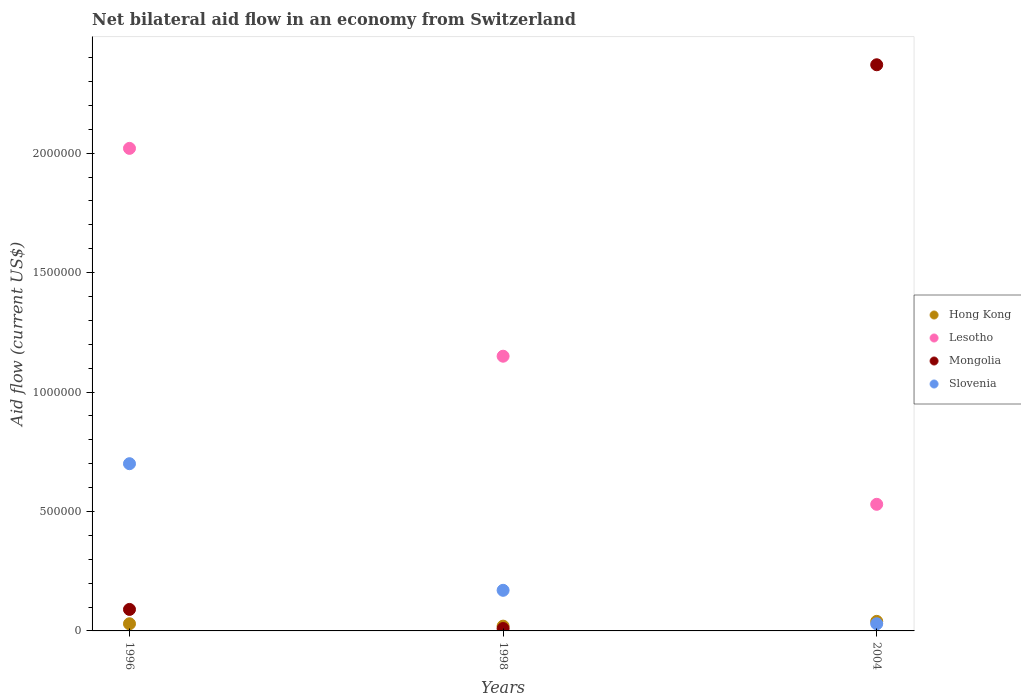Is the number of dotlines equal to the number of legend labels?
Offer a very short reply. Yes. What is the net bilateral aid flow in Slovenia in 1998?
Your answer should be compact. 1.70e+05. Across all years, what is the minimum net bilateral aid flow in Lesotho?
Your answer should be compact. 5.30e+05. In which year was the net bilateral aid flow in Slovenia maximum?
Your answer should be very brief. 1996. In which year was the net bilateral aid flow in Slovenia minimum?
Your answer should be compact. 2004. What is the total net bilateral aid flow in Lesotho in the graph?
Your answer should be compact. 3.70e+06. What is the average net bilateral aid flow in Mongolia per year?
Provide a short and direct response. 8.23e+05. Is the difference between the net bilateral aid flow in Hong Kong in 1996 and 1998 greater than the difference between the net bilateral aid flow in Mongolia in 1996 and 1998?
Your answer should be compact. No. What is the difference between the highest and the second highest net bilateral aid flow in Lesotho?
Your response must be concise. 8.70e+05. What is the difference between the highest and the lowest net bilateral aid flow in Lesotho?
Ensure brevity in your answer.  1.49e+06. In how many years, is the net bilateral aid flow in Mongolia greater than the average net bilateral aid flow in Mongolia taken over all years?
Give a very brief answer. 1. Is it the case that in every year, the sum of the net bilateral aid flow in Lesotho and net bilateral aid flow in Hong Kong  is greater than the sum of net bilateral aid flow in Mongolia and net bilateral aid flow in Slovenia?
Provide a succinct answer. Yes. What is the difference between two consecutive major ticks on the Y-axis?
Provide a succinct answer. 5.00e+05. Are the values on the major ticks of Y-axis written in scientific E-notation?
Give a very brief answer. No. Does the graph contain any zero values?
Your response must be concise. No. Where does the legend appear in the graph?
Your answer should be very brief. Center right. How many legend labels are there?
Make the answer very short. 4. How are the legend labels stacked?
Give a very brief answer. Vertical. What is the title of the graph?
Make the answer very short. Net bilateral aid flow in an economy from Switzerland. What is the label or title of the Y-axis?
Offer a very short reply. Aid flow (current US$). What is the Aid flow (current US$) of Hong Kong in 1996?
Your answer should be very brief. 3.00e+04. What is the Aid flow (current US$) in Lesotho in 1996?
Make the answer very short. 2.02e+06. What is the Aid flow (current US$) of Slovenia in 1996?
Your response must be concise. 7.00e+05. What is the Aid flow (current US$) in Hong Kong in 1998?
Provide a short and direct response. 2.00e+04. What is the Aid flow (current US$) in Lesotho in 1998?
Offer a terse response. 1.15e+06. What is the Aid flow (current US$) of Slovenia in 1998?
Your answer should be compact. 1.70e+05. What is the Aid flow (current US$) of Hong Kong in 2004?
Your answer should be very brief. 4.00e+04. What is the Aid flow (current US$) of Lesotho in 2004?
Provide a succinct answer. 5.30e+05. What is the Aid flow (current US$) in Mongolia in 2004?
Give a very brief answer. 2.37e+06. Across all years, what is the maximum Aid flow (current US$) of Lesotho?
Provide a short and direct response. 2.02e+06. Across all years, what is the maximum Aid flow (current US$) in Mongolia?
Make the answer very short. 2.37e+06. Across all years, what is the maximum Aid flow (current US$) in Slovenia?
Your response must be concise. 7.00e+05. Across all years, what is the minimum Aid flow (current US$) of Lesotho?
Offer a very short reply. 5.30e+05. Across all years, what is the minimum Aid flow (current US$) in Mongolia?
Your answer should be very brief. 10000. Across all years, what is the minimum Aid flow (current US$) in Slovenia?
Keep it short and to the point. 3.00e+04. What is the total Aid flow (current US$) of Lesotho in the graph?
Your answer should be very brief. 3.70e+06. What is the total Aid flow (current US$) of Mongolia in the graph?
Make the answer very short. 2.47e+06. What is the difference between the Aid flow (current US$) of Hong Kong in 1996 and that in 1998?
Offer a terse response. 10000. What is the difference between the Aid flow (current US$) in Lesotho in 1996 and that in 1998?
Keep it short and to the point. 8.70e+05. What is the difference between the Aid flow (current US$) of Slovenia in 1996 and that in 1998?
Keep it short and to the point. 5.30e+05. What is the difference between the Aid flow (current US$) in Lesotho in 1996 and that in 2004?
Offer a terse response. 1.49e+06. What is the difference between the Aid flow (current US$) of Mongolia in 1996 and that in 2004?
Offer a terse response. -2.28e+06. What is the difference between the Aid flow (current US$) of Slovenia in 1996 and that in 2004?
Keep it short and to the point. 6.70e+05. What is the difference between the Aid flow (current US$) of Lesotho in 1998 and that in 2004?
Provide a short and direct response. 6.20e+05. What is the difference between the Aid flow (current US$) of Mongolia in 1998 and that in 2004?
Give a very brief answer. -2.36e+06. What is the difference between the Aid flow (current US$) of Slovenia in 1998 and that in 2004?
Keep it short and to the point. 1.40e+05. What is the difference between the Aid flow (current US$) of Hong Kong in 1996 and the Aid flow (current US$) of Lesotho in 1998?
Keep it short and to the point. -1.12e+06. What is the difference between the Aid flow (current US$) in Lesotho in 1996 and the Aid flow (current US$) in Mongolia in 1998?
Your answer should be compact. 2.01e+06. What is the difference between the Aid flow (current US$) of Lesotho in 1996 and the Aid flow (current US$) of Slovenia in 1998?
Provide a short and direct response. 1.85e+06. What is the difference between the Aid flow (current US$) of Hong Kong in 1996 and the Aid flow (current US$) of Lesotho in 2004?
Ensure brevity in your answer.  -5.00e+05. What is the difference between the Aid flow (current US$) in Hong Kong in 1996 and the Aid flow (current US$) in Mongolia in 2004?
Ensure brevity in your answer.  -2.34e+06. What is the difference between the Aid flow (current US$) of Lesotho in 1996 and the Aid flow (current US$) of Mongolia in 2004?
Your answer should be very brief. -3.50e+05. What is the difference between the Aid flow (current US$) in Lesotho in 1996 and the Aid flow (current US$) in Slovenia in 2004?
Your response must be concise. 1.99e+06. What is the difference between the Aid flow (current US$) of Mongolia in 1996 and the Aid flow (current US$) of Slovenia in 2004?
Provide a succinct answer. 6.00e+04. What is the difference between the Aid flow (current US$) in Hong Kong in 1998 and the Aid flow (current US$) in Lesotho in 2004?
Provide a short and direct response. -5.10e+05. What is the difference between the Aid flow (current US$) in Hong Kong in 1998 and the Aid flow (current US$) in Mongolia in 2004?
Your response must be concise. -2.35e+06. What is the difference between the Aid flow (current US$) of Lesotho in 1998 and the Aid flow (current US$) of Mongolia in 2004?
Provide a short and direct response. -1.22e+06. What is the difference between the Aid flow (current US$) of Lesotho in 1998 and the Aid flow (current US$) of Slovenia in 2004?
Ensure brevity in your answer.  1.12e+06. What is the difference between the Aid flow (current US$) of Mongolia in 1998 and the Aid flow (current US$) of Slovenia in 2004?
Give a very brief answer. -2.00e+04. What is the average Aid flow (current US$) of Hong Kong per year?
Your response must be concise. 3.00e+04. What is the average Aid flow (current US$) of Lesotho per year?
Your answer should be compact. 1.23e+06. What is the average Aid flow (current US$) of Mongolia per year?
Keep it short and to the point. 8.23e+05. What is the average Aid flow (current US$) of Slovenia per year?
Keep it short and to the point. 3.00e+05. In the year 1996, what is the difference between the Aid flow (current US$) of Hong Kong and Aid flow (current US$) of Lesotho?
Provide a succinct answer. -1.99e+06. In the year 1996, what is the difference between the Aid flow (current US$) in Hong Kong and Aid flow (current US$) in Mongolia?
Keep it short and to the point. -6.00e+04. In the year 1996, what is the difference between the Aid flow (current US$) of Hong Kong and Aid flow (current US$) of Slovenia?
Offer a very short reply. -6.70e+05. In the year 1996, what is the difference between the Aid flow (current US$) of Lesotho and Aid flow (current US$) of Mongolia?
Your answer should be compact. 1.93e+06. In the year 1996, what is the difference between the Aid flow (current US$) of Lesotho and Aid flow (current US$) of Slovenia?
Provide a succinct answer. 1.32e+06. In the year 1996, what is the difference between the Aid flow (current US$) in Mongolia and Aid flow (current US$) in Slovenia?
Make the answer very short. -6.10e+05. In the year 1998, what is the difference between the Aid flow (current US$) in Hong Kong and Aid flow (current US$) in Lesotho?
Keep it short and to the point. -1.13e+06. In the year 1998, what is the difference between the Aid flow (current US$) in Hong Kong and Aid flow (current US$) in Slovenia?
Give a very brief answer. -1.50e+05. In the year 1998, what is the difference between the Aid flow (current US$) in Lesotho and Aid flow (current US$) in Mongolia?
Your answer should be very brief. 1.14e+06. In the year 1998, what is the difference between the Aid flow (current US$) in Lesotho and Aid flow (current US$) in Slovenia?
Offer a terse response. 9.80e+05. In the year 2004, what is the difference between the Aid flow (current US$) of Hong Kong and Aid flow (current US$) of Lesotho?
Ensure brevity in your answer.  -4.90e+05. In the year 2004, what is the difference between the Aid flow (current US$) in Hong Kong and Aid flow (current US$) in Mongolia?
Ensure brevity in your answer.  -2.33e+06. In the year 2004, what is the difference between the Aid flow (current US$) of Hong Kong and Aid flow (current US$) of Slovenia?
Keep it short and to the point. 10000. In the year 2004, what is the difference between the Aid flow (current US$) in Lesotho and Aid flow (current US$) in Mongolia?
Give a very brief answer. -1.84e+06. In the year 2004, what is the difference between the Aid flow (current US$) of Lesotho and Aid flow (current US$) of Slovenia?
Your answer should be very brief. 5.00e+05. In the year 2004, what is the difference between the Aid flow (current US$) of Mongolia and Aid flow (current US$) of Slovenia?
Provide a short and direct response. 2.34e+06. What is the ratio of the Aid flow (current US$) of Hong Kong in 1996 to that in 1998?
Ensure brevity in your answer.  1.5. What is the ratio of the Aid flow (current US$) of Lesotho in 1996 to that in 1998?
Provide a succinct answer. 1.76. What is the ratio of the Aid flow (current US$) in Mongolia in 1996 to that in 1998?
Ensure brevity in your answer.  9. What is the ratio of the Aid flow (current US$) in Slovenia in 1996 to that in 1998?
Give a very brief answer. 4.12. What is the ratio of the Aid flow (current US$) in Hong Kong in 1996 to that in 2004?
Provide a short and direct response. 0.75. What is the ratio of the Aid flow (current US$) of Lesotho in 1996 to that in 2004?
Your answer should be compact. 3.81. What is the ratio of the Aid flow (current US$) in Mongolia in 1996 to that in 2004?
Your response must be concise. 0.04. What is the ratio of the Aid flow (current US$) of Slovenia in 1996 to that in 2004?
Provide a succinct answer. 23.33. What is the ratio of the Aid flow (current US$) of Lesotho in 1998 to that in 2004?
Offer a very short reply. 2.17. What is the ratio of the Aid flow (current US$) of Mongolia in 1998 to that in 2004?
Your answer should be very brief. 0. What is the ratio of the Aid flow (current US$) of Slovenia in 1998 to that in 2004?
Ensure brevity in your answer.  5.67. What is the difference between the highest and the second highest Aid flow (current US$) in Lesotho?
Your response must be concise. 8.70e+05. What is the difference between the highest and the second highest Aid flow (current US$) of Mongolia?
Offer a terse response. 2.28e+06. What is the difference between the highest and the second highest Aid flow (current US$) in Slovenia?
Provide a succinct answer. 5.30e+05. What is the difference between the highest and the lowest Aid flow (current US$) in Lesotho?
Ensure brevity in your answer.  1.49e+06. What is the difference between the highest and the lowest Aid flow (current US$) in Mongolia?
Offer a very short reply. 2.36e+06. What is the difference between the highest and the lowest Aid flow (current US$) in Slovenia?
Provide a succinct answer. 6.70e+05. 